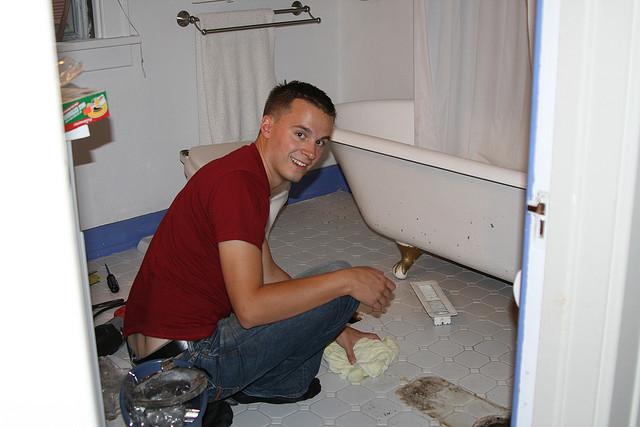What is the man doing over the toilet?
Be succinct. Cleaning. What color is the man's shirt?
Give a very brief answer. Red. Is the man waxing the floor?
Concise answer only. No. How many towels are hanging on the towel rack?
Quick response, please. 1. 